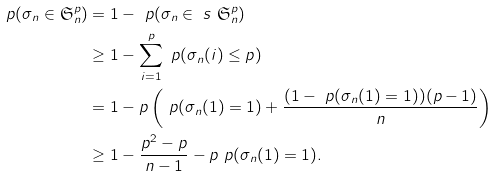<formula> <loc_0><loc_0><loc_500><loc_500>\ p ( \sigma _ { n } \in \mathfrak { S } ^ { p } _ { n } ) & = 1 - \ p ( \sigma _ { n } \in \ s \ \mathfrak { S } ^ { p } _ { n } ) \\ & \geq 1 - \sum _ { i = 1 } ^ { p } \ p ( \sigma _ { n } ( i ) \leq p ) \\ & = 1 - p \left ( \ p ( \sigma _ { n } ( 1 ) = 1 ) + \frac { ( 1 - \ p ( \sigma _ { n } ( 1 ) = 1 ) ) ( p - 1 ) } { n } \right ) \\ & \geq 1 - \frac { p ^ { 2 } - p } { n - 1 } - p \ p ( \sigma _ { n } ( 1 ) = 1 ) .</formula> 